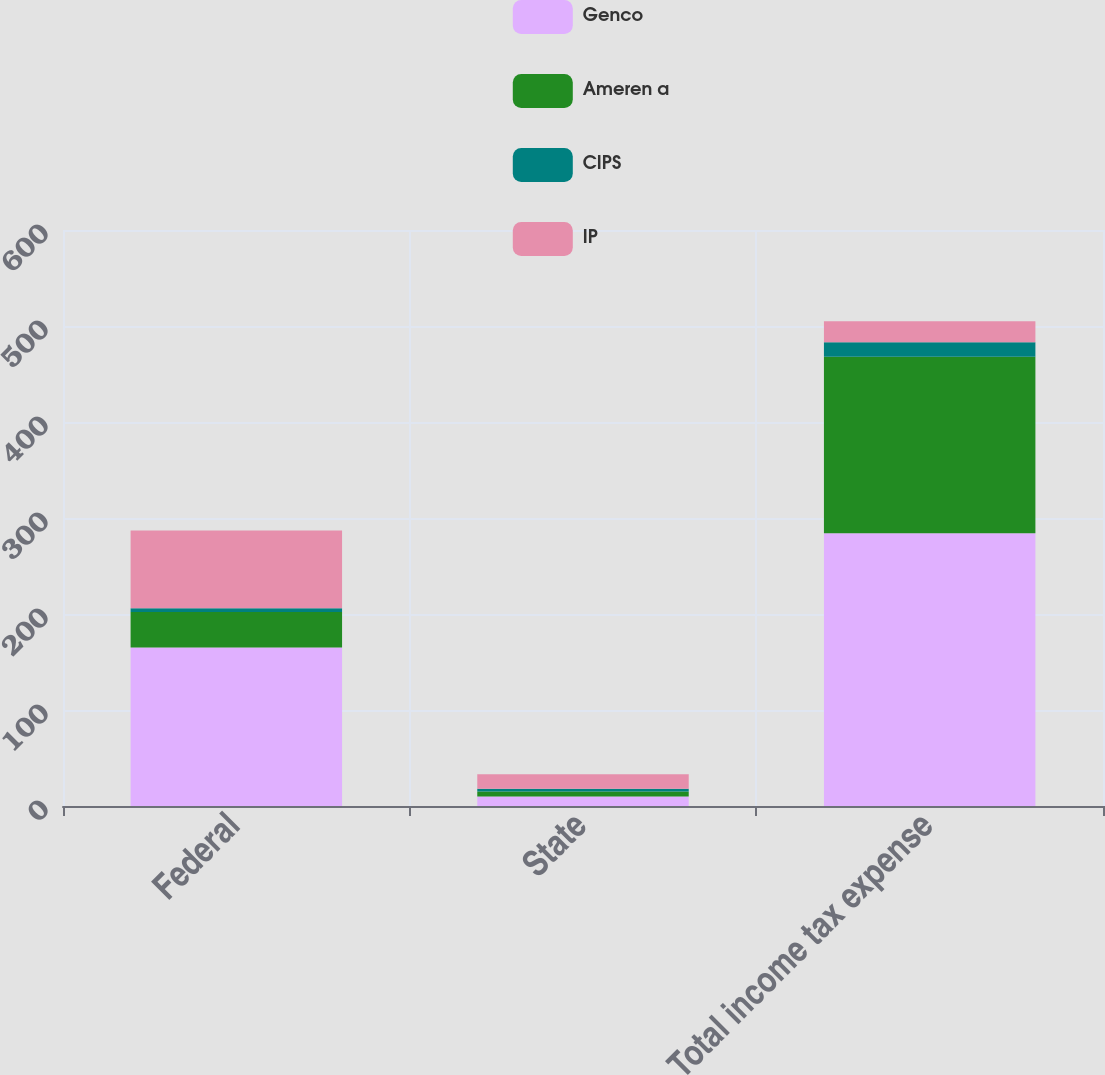Convert chart. <chart><loc_0><loc_0><loc_500><loc_500><stacked_bar_chart><ecel><fcel>Federal<fcel>State<fcel>Total income tax expense<nl><fcel>Genco<fcel>165<fcel>10<fcel>284<nl><fcel>Ameren a<fcel>37<fcel>5<fcel>184<nl><fcel>CIPS<fcel>4<fcel>3<fcel>15<nl><fcel>IP<fcel>81<fcel>15<fcel>22<nl></chart> 